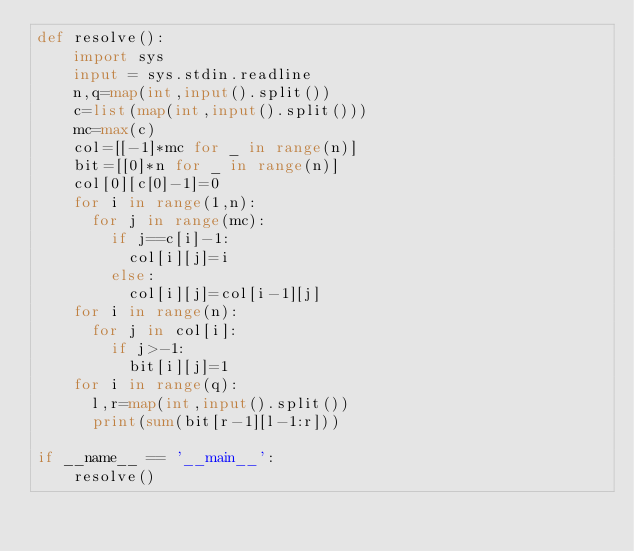<code> <loc_0><loc_0><loc_500><loc_500><_Python_>def resolve():
    import sys
    input = sys.stdin.readline
    n,q=map(int,input().split())
    c=list(map(int,input().split()))
    mc=max(c)
    col=[[-1]*mc for _ in range(n)]
    bit=[[0]*n for _ in range(n)]
    col[0][c[0]-1]=0
    for i in range(1,n):
      for j in range(mc):
        if j==c[i]-1:
          col[i][j]=i
        else:
          col[i][j]=col[i-1][j]
    for i in range(n):
      for j in col[i]:
        if j>-1:
          bit[i][j]=1
    for i in range(q):
      l,r=map(int,input().split())
      print(sum(bit[r-1][l-1:r]))
    
if __name__ == '__main__':
    resolve()</code> 